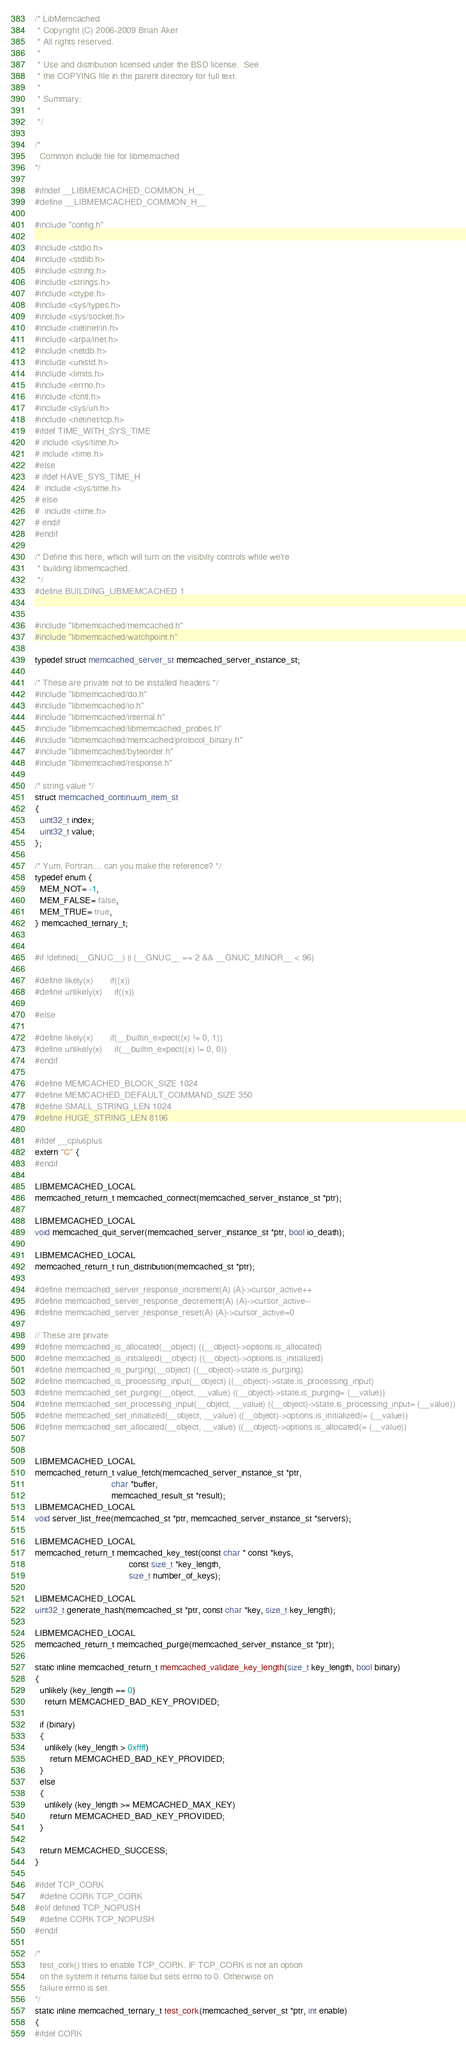<code> <loc_0><loc_0><loc_500><loc_500><_C_>/* LibMemcached
 * Copyright (C) 2006-2009 Brian Aker
 * All rights reserved.
 *
 * Use and distribution licensed under the BSD license.  See
 * the COPYING file in the parent directory for full text.
 *
 * Summary:
 *
 */

/*
  Common include file for libmemached
*/

#ifndef __LIBMEMCACHED_COMMON_H__
#define __LIBMEMCACHED_COMMON_H__

#include "config.h"

#include <stdio.h>
#include <stdlib.h>
#include <string.h>
#include <strings.h>
#include <ctype.h>
#include <sys/types.h>
#include <sys/socket.h>
#include <netinet/in.h>
#include <arpa/inet.h>
#include <netdb.h>
#include <unistd.h>
#include <limits.h>
#include <errno.h>
#include <fcntl.h>
#include <sys/un.h>
#include <netinet/tcp.h>
#ifdef TIME_WITH_SYS_TIME
# include <sys/time.h>
# include <time.h>
#else
# ifdef HAVE_SYS_TIME_H
#  include <sys/time.h>
# else
#  include <time.h>
# endif
#endif

/* Define this here, which will turn on the visibilty controls while we're
 * building libmemcached.
 */
#define BUILDING_LIBMEMCACHED 1


#include "libmemcached/memcached.h"
#include "libmemcached/watchpoint.h"

typedef struct memcached_server_st memcached_server_instance_st;

/* These are private not to be installed headers */
#include "libmemcached/do.h"
#include "libmemcached/io.h"
#include "libmemcached/internal.h"
#include "libmemcached/libmemcached_probes.h"
#include "libmemcached/memcached/protocol_binary.h"
#include "libmemcached/byteorder.h"
#include "libmemcached/response.h"

/* string value */
struct memcached_continuum_item_st
{
  uint32_t index;
  uint32_t value;
};

/* Yum, Fortran.... can you make the reference? */
typedef enum {
  MEM_NOT= -1,
  MEM_FALSE= false,
  MEM_TRUE= true,
} memcached_ternary_t;


#if !defined(__GNUC__) || (__GNUC__ == 2 && __GNUC_MINOR__ < 96)

#define likely(x)       if((x))
#define unlikely(x)     if((x))

#else

#define likely(x)       if(__builtin_expect((x) != 0, 1))
#define unlikely(x)     if(__builtin_expect((x) != 0, 0))
#endif

#define MEMCACHED_BLOCK_SIZE 1024
#define MEMCACHED_DEFAULT_COMMAND_SIZE 350
#define SMALL_STRING_LEN 1024
#define HUGE_STRING_LEN 8196

#ifdef __cplusplus
extern "C" {
#endif

LIBMEMCACHED_LOCAL
memcached_return_t memcached_connect(memcached_server_instance_st *ptr);

LIBMEMCACHED_LOCAL
void memcached_quit_server(memcached_server_instance_st *ptr, bool io_death);

LIBMEMCACHED_LOCAL
memcached_return_t run_distribution(memcached_st *ptr);

#define memcached_server_response_increment(A) (A)->cursor_active++
#define memcached_server_response_decrement(A) (A)->cursor_active--
#define memcached_server_response_reset(A) (A)->cursor_active=0

// These are private 
#define memcached_is_allocated(__object) ((__object)->options.is_allocated)
#define memcached_is_initialized(__object) ((__object)->options.is_initialized)
#define memcached_is_purging(__object) ((__object)->state.is_purging)
#define memcached_is_processing_input(__object) ((__object)->state.is_processing_input)
#define memcached_set_purging(__object, __value) ((__object)->state.is_purging= (__value))
#define memcached_set_processing_input(__object, __value) ((__object)->state.is_processing_input= (__value))
#define memcached_set_initialized(__object, __value) ((__object)->options.is_initialized(= (__value))
#define memcached_set_allocated(__object, __value) ((__object)->options.is_allocated(= (__value))


LIBMEMCACHED_LOCAL
memcached_return_t value_fetch(memcached_server_instance_st *ptr,
                               char *buffer,
                               memcached_result_st *result);
LIBMEMCACHED_LOCAL
void server_list_free(memcached_st *ptr, memcached_server_instance_st *servers);

LIBMEMCACHED_LOCAL
memcached_return_t memcached_key_test(const char * const *keys,
                                      const size_t *key_length,
                                      size_t number_of_keys);

LIBMEMCACHED_LOCAL
uint32_t generate_hash(memcached_st *ptr, const char *key, size_t key_length);

LIBMEMCACHED_LOCAL
memcached_return_t memcached_purge(memcached_server_instance_st *ptr);

static inline memcached_return_t memcached_validate_key_length(size_t key_length, bool binary)
{
  unlikely (key_length == 0)
    return MEMCACHED_BAD_KEY_PROVIDED;

  if (binary)
  {
    unlikely (key_length > 0xffff)
      return MEMCACHED_BAD_KEY_PROVIDED;
  }
  else
  {
    unlikely (key_length >= MEMCACHED_MAX_KEY)
      return MEMCACHED_BAD_KEY_PROVIDED;
  }

  return MEMCACHED_SUCCESS;
}

#ifdef TCP_CORK
  #define CORK TCP_CORK
#elif defined TCP_NOPUSH
  #define CORK TCP_NOPUSH
#endif

/*
  test_cork() tries to enable TCP_CORK. IF TCP_CORK is not an option
  on the system it returns false but sets errno to 0. Otherwise on
  failure errno is set.
*/
static inline memcached_ternary_t test_cork(memcached_server_st *ptr, int enable)
{
#ifdef CORK</code> 